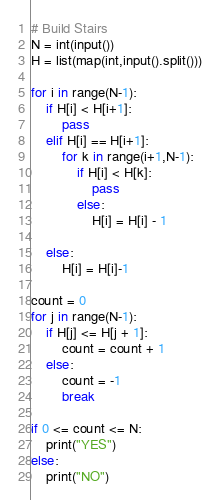Convert code to text. <code><loc_0><loc_0><loc_500><loc_500><_Python_># Build Stairs
N = int(input())
H = list(map(int,input().split()))

for i in range(N-1):
    if H[i] < H[i+1]:
        pass
    elif H[i] == H[i+1]:
        for k in range(i+1,N-1):
            if H[i] < H[k]:
                pass
            else:
                H[i] = H[i] - 1

    else:
        H[i] = H[i]-1

count = 0
for j in range(N-1):
    if H[j] <= H[j + 1]:
        count = count + 1
    else:
        count = -1
        break

if 0 <= count <= N:
    print("YES")
else:
    print("NO")
</code> 